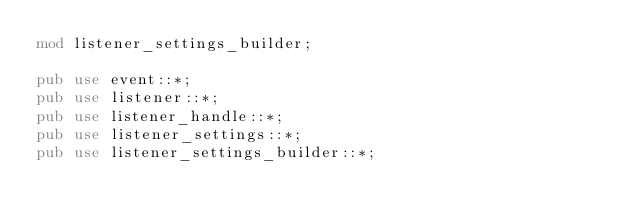<code> <loc_0><loc_0><loc_500><loc_500><_Rust_>mod listener_settings_builder;

pub use event::*;
pub use listener::*;
pub use listener_handle::*;
pub use listener_settings::*;
pub use listener_settings_builder::*;
</code> 